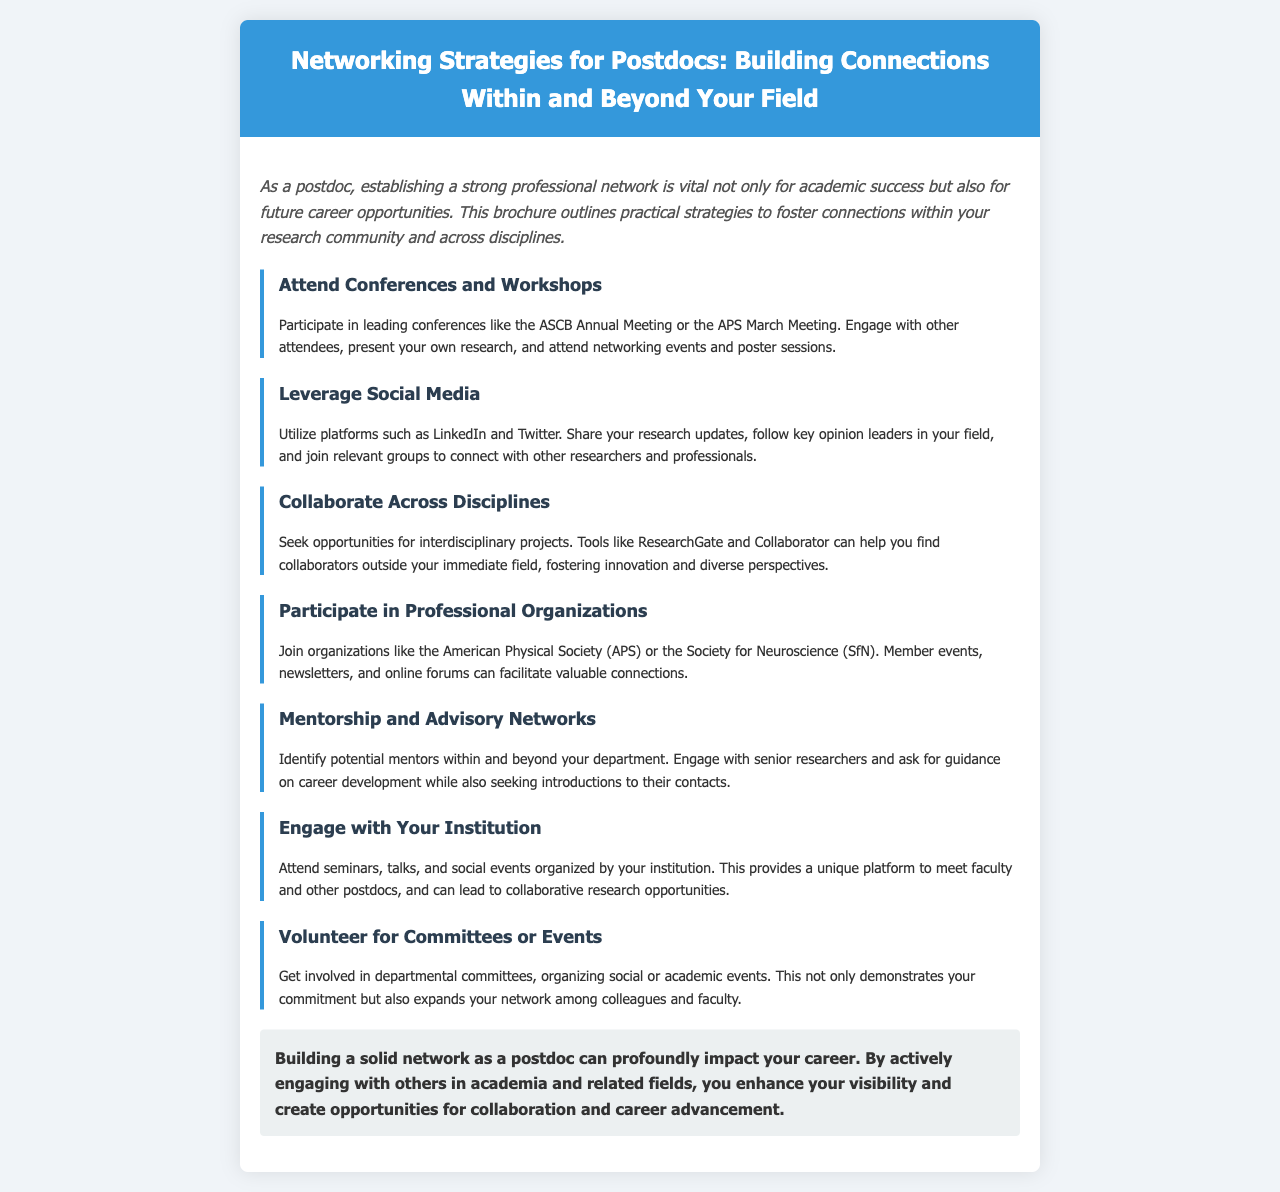What is the main focus of the brochure? The brochure outlines strategies for building professional connections as a postdoc.
Answer: Networking Strategies for Postdocs Which organization is mentioned for joining in networking? The document suggests joining professional organizations to enhance networking opportunities.
Answer: American Physical Society (APS) What type of social media platforms are recommended? The brochure recommends using social media platforms for professional networking.
Answer: LinkedIn and Twitter How many strategies for networking are outlined in the brochure? Counting the listed strategies provides the total number of networking strategies presented.
Answer: Seven What section discusses working with others outside one's field? The document highlights interdisciplinary collaboration as part of networking.
Answer: Collaborate Across Disciplines What is the purpose of volunteering according to the brochure? Volunteering is suggested as a way to demonstrate commitment and expand the network.
Answer: Expand your network among colleagues and faculty Which concept emphasizes the importance of gaining guidance and introductions? Mentorship is discussed as a key element of networking among postdocs.
Answer: Mentorship and Advisory Networks 